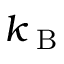<formula> <loc_0><loc_0><loc_500><loc_500>k _ { B }</formula> 